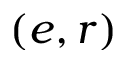<formula> <loc_0><loc_0><loc_500><loc_500>( e , r )</formula> 